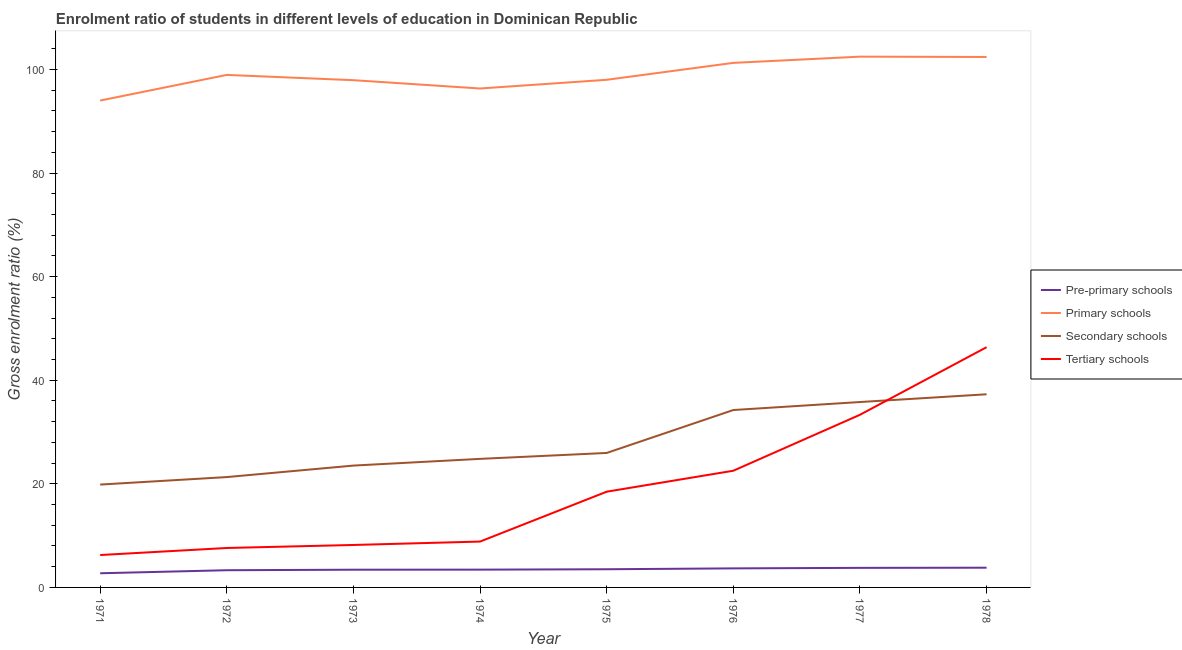Does the line corresponding to gross enrolment ratio in primary schools intersect with the line corresponding to gross enrolment ratio in secondary schools?
Provide a short and direct response. No. What is the gross enrolment ratio in primary schools in 1972?
Your response must be concise. 98.95. Across all years, what is the maximum gross enrolment ratio in primary schools?
Keep it short and to the point. 102.47. Across all years, what is the minimum gross enrolment ratio in pre-primary schools?
Offer a very short reply. 2.73. What is the total gross enrolment ratio in primary schools in the graph?
Offer a terse response. 791.33. What is the difference between the gross enrolment ratio in tertiary schools in 1971 and that in 1976?
Make the answer very short. -16.27. What is the difference between the gross enrolment ratio in pre-primary schools in 1978 and the gross enrolment ratio in secondary schools in 1973?
Give a very brief answer. -19.71. What is the average gross enrolment ratio in primary schools per year?
Make the answer very short. 98.92. In the year 1975, what is the difference between the gross enrolment ratio in primary schools and gross enrolment ratio in pre-primary schools?
Provide a short and direct response. 94.49. In how many years, is the gross enrolment ratio in tertiary schools greater than 56 %?
Keep it short and to the point. 0. What is the ratio of the gross enrolment ratio in primary schools in 1972 to that in 1978?
Provide a succinct answer. 0.97. Is the gross enrolment ratio in tertiary schools in 1973 less than that in 1977?
Provide a succinct answer. Yes. What is the difference between the highest and the second highest gross enrolment ratio in tertiary schools?
Offer a terse response. 13.05. What is the difference between the highest and the lowest gross enrolment ratio in primary schools?
Your answer should be very brief. 8.47. In how many years, is the gross enrolment ratio in pre-primary schools greater than the average gross enrolment ratio in pre-primary schools taken over all years?
Offer a terse response. 4. Is the sum of the gross enrolment ratio in pre-primary schools in 1974 and 1977 greater than the maximum gross enrolment ratio in secondary schools across all years?
Offer a terse response. No. Is it the case that in every year, the sum of the gross enrolment ratio in pre-primary schools and gross enrolment ratio in primary schools is greater than the gross enrolment ratio in secondary schools?
Ensure brevity in your answer.  Yes. Does the gross enrolment ratio in tertiary schools monotonically increase over the years?
Your response must be concise. Yes. How many lines are there?
Make the answer very short. 4. Are the values on the major ticks of Y-axis written in scientific E-notation?
Make the answer very short. No. Does the graph contain grids?
Your answer should be very brief. No. What is the title of the graph?
Keep it short and to the point. Enrolment ratio of students in different levels of education in Dominican Republic. Does "Management rating" appear as one of the legend labels in the graph?
Offer a very short reply. No. What is the Gross enrolment ratio (%) of Pre-primary schools in 1971?
Give a very brief answer. 2.73. What is the Gross enrolment ratio (%) in Primary schools in 1971?
Make the answer very short. 93.99. What is the Gross enrolment ratio (%) of Secondary schools in 1971?
Ensure brevity in your answer.  19.86. What is the Gross enrolment ratio (%) of Tertiary schools in 1971?
Give a very brief answer. 6.25. What is the Gross enrolment ratio (%) of Pre-primary schools in 1972?
Offer a very short reply. 3.32. What is the Gross enrolment ratio (%) of Primary schools in 1972?
Give a very brief answer. 98.95. What is the Gross enrolment ratio (%) of Secondary schools in 1972?
Give a very brief answer. 21.3. What is the Gross enrolment ratio (%) of Tertiary schools in 1972?
Make the answer very short. 7.61. What is the Gross enrolment ratio (%) in Pre-primary schools in 1973?
Provide a succinct answer. 3.42. What is the Gross enrolment ratio (%) in Primary schools in 1973?
Your answer should be very brief. 97.93. What is the Gross enrolment ratio (%) of Secondary schools in 1973?
Make the answer very short. 23.52. What is the Gross enrolment ratio (%) of Tertiary schools in 1973?
Ensure brevity in your answer.  8.2. What is the Gross enrolment ratio (%) in Pre-primary schools in 1974?
Give a very brief answer. 3.43. What is the Gross enrolment ratio (%) of Primary schools in 1974?
Ensure brevity in your answer.  96.32. What is the Gross enrolment ratio (%) of Secondary schools in 1974?
Offer a terse response. 24.82. What is the Gross enrolment ratio (%) of Tertiary schools in 1974?
Offer a terse response. 8.85. What is the Gross enrolment ratio (%) of Pre-primary schools in 1975?
Your response must be concise. 3.51. What is the Gross enrolment ratio (%) of Primary schools in 1975?
Offer a terse response. 98. What is the Gross enrolment ratio (%) in Secondary schools in 1975?
Make the answer very short. 25.96. What is the Gross enrolment ratio (%) in Tertiary schools in 1975?
Offer a terse response. 18.48. What is the Gross enrolment ratio (%) of Pre-primary schools in 1976?
Offer a very short reply. 3.68. What is the Gross enrolment ratio (%) of Primary schools in 1976?
Ensure brevity in your answer.  101.27. What is the Gross enrolment ratio (%) in Secondary schools in 1976?
Provide a short and direct response. 34.25. What is the Gross enrolment ratio (%) in Tertiary schools in 1976?
Provide a short and direct response. 22.53. What is the Gross enrolment ratio (%) of Pre-primary schools in 1977?
Offer a very short reply. 3.78. What is the Gross enrolment ratio (%) of Primary schools in 1977?
Your answer should be compact. 102.47. What is the Gross enrolment ratio (%) of Secondary schools in 1977?
Provide a short and direct response. 35.79. What is the Gross enrolment ratio (%) in Tertiary schools in 1977?
Make the answer very short. 33.33. What is the Gross enrolment ratio (%) of Pre-primary schools in 1978?
Make the answer very short. 3.81. What is the Gross enrolment ratio (%) of Primary schools in 1978?
Your answer should be compact. 102.41. What is the Gross enrolment ratio (%) in Secondary schools in 1978?
Your response must be concise. 37.29. What is the Gross enrolment ratio (%) in Tertiary schools in 1978?
Your response must be concise. 46.38. Across all years, what is the maximum Gross enrolment ratio (%) in Pre-primary schools?
Give a very brief answer. 3.81. Across all years, what is the maximum Gross enrolment ratio (%) of Primary schools?
Provide a succinct answer. 102.47. Across all years, what is the maximum Gross enrolment ratio (%) of Secondary schools?
Keep it short and to the point. 37.29. Across all years, what is the maximum Gross enrolment ratio (%) in Tertiary schools?
Keep it short and to the point. 46.38. Across all years, what is the minimum Gross enrolment ratio (%) of Pre-primary schools?
Offer a very short reply. 2.73. Across all years, what is the minimum Gross enrolment ratio (%) in Primary schools?
Keep it short and to the point. 93.99. Across all years, what is the minimum Gross enrolment ratio (%) of Secondary schools?
Your answer should be compact. 19.86. Across all years, what is the minimum Gross enrolment ratio (%) in Tertiary schools?
Make the answer very short. 6.25. What is the total Gross enrolment ratio (%) in Pre-primary schools in the graph?
Keep it short and to the point. 27.69. What is the total Gross enrolment ratio (%) of Primary schools in the graph?
Keep it short and to the point. 791.33. What is the total Gross enrolment ratio (%) of Secondary schools in the graph?
Your response must be concise. 222.79. What is the total Gross enrolment ratio (%) in Tertiary schools in the graph?
Your response must be concise. 151.64. What is the difference between the Gross enrolment ratio (%) in Pre-primary schools in 1971 and that in 1972?
Your answer should be very brief. -0.59. What is the difference between the Gross enrolment ratio (%) in Primary schools in 1971 and that in 1972?
Keep it short and to the point. -4.95. What is the difference between the Gross enrolment ratio (%) in Secondary schools in 1971 and that in 1972?
Make the answer very short. -1.45. What is the difference between the Gross enrolment ratio (%) of Tertiary schools in 1971 and that in 1972?
Offer a terse response. -1.36. What is the difference between the Gross enrolment ratio (%) of Pre-primary schools in 1971 and that in 1973?
Your response must be concise. -0.69. What is the difference between the Gross enrolment ratio (%) of Primary schools in 1971 and that in 1973?
Your answer should be compact. -3.93. What is the difference between the Gross enrolment ratio (%) in Secondary schools in 1971 and that in 1973?
Provide a short and direct response. -3.67. What is the difference between the Gross enrolment ratio (%) of Tertiary schools in 1971 and that in 1973?
Provide a succinct answer. -1.94. What is the difference between the Gross enrolment ratio (%) of Pre-primary schools in 1971 and that in 1974?
Provide a short and direct response. -0.7. What is the difference between the Gross enrolment ratio (%) in Primary schools in 1971 and that in 1974?
Provide a short and direct response. -2.33. What is the difference between the Gross enrolment ratio (%) of Secondary schools in 1971 and that in 1974?
Your answer should be very brief. -4.96. What is the difference between the Gross enrolment ratio (%) of Tertiary schools in 1971 and that in 1974?
Ensure brevity in your answer.  -2.6. What is the difference between the Gross enrolment ratio (%) of Pre-primary schools in 1971 and that in 1975?
Your answer should be compact. -0.78. What is the difference between the Gross enrolment ratio (%) in Primary schools in 1971 and that in 1975?
Offer a terse response. -4.01. What is the difference between the Gross enrolment ratio (%) in Secondary schools in 1971 and that in 1975?
Provide a succinct answer. -6.1. What is the difference between the Gross enrolment ratio (%) in Tertiary schools in 1971 and that in 1975?
Offer a terse response. -12.23. What is the difference between the Gross enrolment ratio (%) of Pre-primary schools in 1971 and that in 1976?
Provide a succinct answer. -0.94. What is the difference between the Gross enrolment ratio (%) of Primary schools in 1971 and that in 1976?
Your response must be concise. -7.27. What is the difference between the Gross enrolment ratio (%) in Secondary schools in 1971 and that in 1976?
Your response must be concise. -14.39. What is the difference between the Gross enrolment ratio (%) in Tertiary schools in 1971 and that in 1976?
Provide a succinct answer. -16.27. What is the difference between the Gross enrolment ratio (%) in Pre-primary schools in 1971 and that in 1977?
Your answer should be compact. -1.04. What is the difference between the Gross enrolment ratio (%) in Primary schools in 1971 and that in 1977?
Keep it short and to the point. -8.47. What is the difference between the Gross enrolment ratio (%) of Secondary schools in 1971 and that in 1977?
Your answer should be very brief. -15.93. What is the difference between the Gross enrolment ratio (%) in Tertiary schools in 1971 and that in 1977?
Offer a very short reply. -27.08. What is the difference between the Gross enrolment ratio (%) in Pre-primary schools in 1971 and that in 1978?
Offer a terse response. -1.07. What is the difference between the Gross enrolment ratio (%) in Primary schools in 1971 and that in 1978?
Make the answer very short. -8.41. What is the difference between the Gross enrolment ratio (%) of Secondary schools in 1971 and that in 1978?
Keep it short and to the point. -17.43. What is the difference between the Gross enrolment ratio (%) of Tertiary schools in 1971 and that in 1978?
Ensure brevity in your answer.  -40.12. What is the difference between the Gross enrolment ratio (%) in Pre-primary schools in 1972 and that in 1973?
Offer a very short reply. -0.1. What is the difference between the Gross enrolment ratio (%) of Primary schools in 1972 and that in 1973?
Give a very brief answer. 1.02. What is the difference between the Gross enrolment ratio (%) of Secondary schools in 1972 and that in 1973?
Keep it short and to the point. -2.22. What is the difference between the Gross enrolment ratio (%) in Tertiary schools in 1972 and that in 1973?
Ensure brevity in your answer.  -0.58. What is the difference between the Gross enrolment ratio (%) in Pre-primary schools in 1972 and that in 1974?
Provide a succinct answer. -0.11. What is the difference between the Gross enrolment ratio (%) in Primary schools in 1972 and that in 1974?
Your response must be concise. 2.62. What is the difference between the Gross enrolment ratio (%) in Secondary schools in 1972 and that in 1974?
Keep it short and to the point. -3.51. What is the difference between the Gross enrolment ratio (%) in Tertiary schools in 1972 and that in 1974?
Offer a terse response. -1.24. What is the difference between the Gross enrolment ratio (%) in Pre-primary schools in 1972 and that in 1975?
Give a very brief answer. -0.19. What is the difference between the Gross enrolment ratio (%) in Primary schools in 1972 and that in 1975?
Provide a succinct answer. 0.94. What is the difference between the Gross enrolment ratio (%) in Secondary schools in 1972 and that in 1975?
Your response must be concise. -4.66. What is the difference between the Gross enrolment ratio (%) of Tertiary schools in 1972 and that in 1975?
Give a very brief answer. -10.87. What is the difference between the Gross enrolment ratio (%) in Pre-primary schools in 1972 and that in 1976?
Provide a succinct answer. -0.36. What is the difference between the Gross enrolment ratio (%) in Primary schools in 1972 and that in 1976?
Provide a succinct answer. -2.32. What is the difference between the Gross enrolment ratio (%) of Secondary schools in 1972 and that in 1976?
Offer a very short reply. -12.94. What is the difference between the Gross enrolment ratio (%) of Tertiary schools in 1972 and that in 1976?
Your answer should be compact. -14.91. What is the difference between the Gross enrolment ratio (%) of Pre-primary schools in 1972 and that in 1977?
Ensure brevity in your answer.  -0.46. What is the difference between the Gross enrolment ratio (%) in Primary schools in 1972 and that in 1977?
Provide a short and direct response. -3.52. What is the difference between the Gross enrolment ratio (%) in Secondary schools in 1972 and that in 1977?
Your answer should be compact. -14.49. What is the difference between the Gross enrolment ratio (%) of Tertiary schools in 1972 and that in 1977?
Make the answer very short. -25.71. What is the difference between the Gross enrolment ratio (%) of Pre-primary schools in 1972 and that in 1978?
Keep it short and to the point. -0.49. What is the difference between the Gross enrolment ratio (%) in Primary schools in 1972 and that in 1978?
Keep it short and to the point. -3.46. What is the difference between the Gross enrolment ratio (%) of Secondary schools in 1972 and that in 1978?
Offer a very short reply. -15.98. What is the difference between the Gross enrolment ratio (%) in Tertiary schools in 1972 and that in 1978?
Keep it short and to the point. -38.76. What is the difference between the Gross enrolment ratio (%) of Pre-primary schools in 1973 and that in 1974?
Give a very brief answer. -0.01. What is the difference between the Gross enrolment ratio (%) in Primary schools in 1973 and that in 1974?
Provide a short and direct response. 1.6. What is the difference between the Gross enrolment ratio (%) of Secondary schools in 1973 and that in 1974?
Your response must be concise. -1.3. What is the difference between the Gross enrolment ratio (%) in Tertiary schools in 1973 and that in 1974?
Give a very brief answer. -0.66. What is the difference between the Gross enrolment ratio (%) of Pre-primary schools in 1973 and that in 1975?
Offer a terse response. -0.09. What is the difference between the Gross enrolment ratio (%) in Primary schools in 1973 and that in 1975?
Provide a succinct answer. -0.07. What is the difference between the Gross enrolment ratio (%) of Secondary schools in 1973 and that in 1975?
Provide a short and direct response. -2.44. What is the difference between the Gross enrolment ratio (%) of Tertiary schools in 1973 and that in 1975?
Keep it short and to the point. -10.28. What is the difference between the Gross enrolment ratio (%) of Pre-primary schools in 1973 and that in 1976?
Offer a terse response. -0.26. What is the difference between the Gross enrolment ratio (%) in Primary schools in 1973 and that in 1976?
Offer a terse response. -3.34. What is the difference between the Gross enrolment ratio (%) of Secondary schools in 1973 and that in 1976?
Your response must be concise. -10.73. What is the difference between the Gross enrolment ratio (%) of Tertiary schools in 1973 and that in 1976?
Your answer should be compact. -14.33. What is the difference between the Gross enrolment ratio (%) of Pre-primary schools in 1973 and that in 1977?
Give a very brief answer. -0.36. What is the difference between the Gross enrolment ratio (%) in Primary schools in 1973 and that in 1977?
Your answer should be compact. -4.54. What is the difference between the Gross enrolment ratio (%) of Secondary schools in 1973 and that in 1977?
Your answer should be very brief. -12.27. What is the difference between the Gross enrolment ratio (%) in Tertiary schools in 1973 and that in 1977?
Your answer should be very brief. -25.13. What is the difference between the Gross enrolment ratio (%) of Pre-primary schools in 1973 and that in 1978?
Make the answer very short. -0.39. What is the difference between the Gross enrolment ratio (%) of Primary schools in 1973 and that in 1978?
Provide a succinct answer. -4.48. What is the difference between the Gross enrolment ratio (%) of Secondary schools in 1973 and that in 1978?
Make the answer very short. -13.77. What is the difference between the Gross enrolment ratio (%) of Tertiary schools in 1973 and that in 1978?
Give a very brief answer. -38.18. What is the difference between the Gross enrolment ratio (%) in Pre-primary schools in 1974 and that in 1975?
Offer a very short reply. -0.08. What is the difference between the Gross enrolment ratio (%) of Primary schools in 1974 and that in 1975?
Keep it short and to the point. -1.68. What is the difference between the Gross enrolment ratio (%) in Secondary schools in 1974 and that in 1975?
Your answer should be compact. -1.14. What is the difference between the Gross enrolment ratio (%) of Tertiary schools in 1974 and that in 1975?
Your answer should be very brief. -9.63. What is the difference between the Gross enrolment ratio (%) in Pre-primary schools in 1974 and that in 1976?
Provide a succinct answer. -0.24. What is the difference between the Gross enrolment ratio (%) of Primary schools in 1974 and that in 1976?
Your response must be concise. -4.95. What is the difference between the Gross enrolment ratio (%) in Secondary schools in 1974 and that in 1976?
Your answer should be very brief. -9.43. What is the difference between the Gross enrolment ratio (%) in Tertiary schools in 1974 and that in 1976?
Give a very brief answer. -13.67. What is the difference between the Gross enrolment ratio (%) of Pre-primary schools in 1974 and that in 1977?
Your response must be concise. -0.34. What is the difference between the Gross enrolment ratio (%) in Primary schools in 1974 and that in 1977?
Your response must be concise. -6.15. What is the difference between the Gross enrolment ratio (%) of Secondary schools in 1974 and that in 1977?
Your answer should be very brief. -10.97. What is the difference between the Gross enrolment ratio (%) in Tertiary schools in 1974 and that in 1977?
Offer a very short reply. -24.47. What is the difference between the Gross enrolment ratio (%) in Pre-primary schools in 1974 and that in 1978?
Your answer should be compact. -0.37. What is the difference between the Gross enrolment ratio (%) of Primary schools in 1974 and that in 1978?
Give a very brief answer. -6.09. What is the difference between the Gross enrolment ratio (%) of Secondary schools in 1974 and that in 1978?
Provide a short and direct response. -12.47. What is the difference between the Gross enrolment ratio (%) in Tertiary schools in 1974 and that in 1978?
Your answer should be very brief. -37.52. What is the difference between the Gross enrolment ratio (%) in Pre-primary schools in 1975 and that in 1976?
Offer a very short reply. -0.17. What is the difference between the Gross enrolment ratio (%) in Primary schools in 1975 and that in 1976?
Make the answer very short. -3.27. What is the difference between the Gross enrolment ratio (%) in Secondary schools in 1975 and that in 1976?
Your response must be concise. -8.29. What is the difference between the Gross enrolment ratio (%) of Tertiary schools in 1975 and that in 1976?
Your response must be concise. -4.05. What is the difference between the Gross enrolment ratio (%) in Pre-primary schools in 1975 and that in 1977?
Provide a succinct answer. -0.27. What is the difference between the Gross enrolment ratio (%) of Primary schools in 1975 and that in 1977?
Your answer should be compact. -4.47. What is the difference between the Gross enrolment ratio (%) in Secondary schools in 1975 and that in 1977?
Provide a succinct answer. -9.83. What is the difference between the Gross enrolment ratio (%) in Tertiary schools in 1975 and that in 1977?
Your response must be concise. -14.85. What is the difference between the Gross enrolment ratio (%) of Pre-primary schools in 1975 and that in 1978?
Your answer should be very brief. -0.3. What is the difference between the Gross enrolment ratio (%) of Primary schools in 1975 and that in 1978?
Your response must be concise. -4.41. What is the difference between the Gross enrolment ratio (%) of Secondary schools in 1975 and that in 1978?
Your answer should be compact. -11.33. What is the difference between the Gross enrolment ratio (%) of Tertiary schools in 1975 and that in 1978?
Provide a short and direct response. -27.9. What is the difference between the Gross enrolment ratio (%) in Pre-primary schools in 1976 and that in 1977?
Your answer should be compact. -0.1. What is the difference between the Gross enrolment ratio (%) of Primary schools in 1976 and that in 1977?
Your answer should be compact. -1.2. What is the difference between the Gross enrolment ratio (%) of Secondary schools in 1976 and that in 1977?
Give a very brief answer. -1.54. What is the difference between the Gross enrolment ratio (%) of Tertiary schools in 1976 and that in 1977?
Your answer should be very brief. -10.8. What is the difference between the Gross enrolment ratio (%) in Pre-primary schools in 1976 and that in 1978?
Provide a short and direct response. -0.13. What is the difference between the Gross enrolment ratio (%) of Primary schools in 1976 and that in 1978?
Provide a succinct answer. -1.14. What is the difference between the Gross enrolment ratio (%) of Secondary schools in 1976 and that in 1978?
Offer a very short reply. -3.04. What is the difference between the Gross enrolment ratio (%) of Tertiary schools in 1976 and that in 1978?
Provide a short and direct response. -23.85. What is the difference between the Gross enrolment ratio (%) of Pre-primary schools in 1977 and that in 1978?
Your answer should be very brief. -0.03. What is the difference between the Gross enrolment ratio (%) in Primary schools in 1977 and that in 1978?
Your response must be concise. 0.06. What is the difference between the Gross enrolment ratio (%) of Secondary schools in 1977 and that in 1978?
Give a very brief answer. -1.5. What is the difference between the Gross enrolment ratio (%) in Tertiary schools in 1977 and that in 1978?
Offer a very short reply. -13.05. What is the difference between the Gross enrolment ratio (%) in Pre-primary schools in 1971 and the Gross enrolment ratio (%) in Primary schools in 1972?
Your answer should be compact. -96.21. What is the difference between the Gross enrolment ratio (%) in Pre-primary schools in 1971 and the Gross enrolment ratio (%) in Secondary schools in 1972?
Offer a terse response. -18.57. What is the difference between the Gross enrolment ratio (%) of Pre-primary schools in 1971 and the Gross enrolment ratio (%) of Tertiary schools in 1972?
Keep it short and to the point. -4.88. What is the difference between the Gross enrolment ratio (%) in Primary schools in 1971 and the Gross enrolment ratio (%) in Secondary schools in 1972?
Provide a succinct answer. 72.69. What is the difference between the Gross enrolment ratio (%) of Primary schools in 1971 and the Gross enrolment ratio (%) of Tertiary schools in 1972?
Provide a succinct answer. 86.38. What is the difference between the Gross enrolment ratio (%) in Secondary schools in 1971 and the Gross enrolment ratio (%) in Tertiary schools in 1972?
Provide a succinct answer. 12.24. What is the difference between the Gross enrolment ratio (%) of Pre-primary schools in 1971 and the Gross enrolment ratio (%) of Primary schools in 1973?
Your answer should be compact. -95.19. What is the difference between the Gross enrolment ratio (%) in Pre-primary schools in 1971 and the Gross enrolment ratio (%) in Secondary schools in 1973?
Your response must be concise. -20.79. What is the difference between the Gross enrolment ratio (%) of Pre-primary schools in 1971 and the Gross enrolment ratio (%) of Tertiary schools in 1973?
Provide a succinct answer. -5.46. What is the difference between the Gross enrolment ratio (%) in Primary schools in 1971 and the Gross enrolment ratio (%) in Secondary schools in 1973?
Give a very brief answer. 70.47. What is the difference between the Gross enrolment ratio (%) of Primary schools in 1971 and the Gross enrolment ratio (%) of Tertiary schools in 1973?
Your answer should be very brief. 85.8. What is the difference between the Gross enrolment ratio (%) in Secondary schools in 1971 and the Gross enrolment ratio (%) in Tertiary schools in 1973?
Ensure brevity in your answer.  11.66. What is the difference between the Gross enrolment ratio (%) in Pre-primary schools in 1971 and the Gross enrolment ratio (%) in Primary schools in 1974?
Provide a succinct answer. -93.59. What is the difference between the Gross enrolment ratio (%) in Pre-primary schools in 1971 and the Gross enrolment ratio (%) in Secondary schools in 1974?
Your response must be concise. -22.08. What is the difference between the Gross enrolment ratio (%) of Pre-primary schools in 1971 and the Gross enrolment ratio (%) of Tertiary schools in 1974?
Offer a terse response. -6.12. What is the difference between the Gross enrolment ratio (%) of Primary schools in 1971 and the Gross enrolment ratio (%) of Secondary schools in 1974?
Offer a very short reply. 69.18. What is the difference between the Gross enrolment ratio (%) in Primary schools in 1971 and the Gross enrolment ratio (%) in Tertiary schools in 1974?
Keep it short and to the point. 85.14. What is the difference between the Gross enrolment ratio (%) of Secondary schools in 1971 and the Gross enrolment ratio (%) of Tertiary schools in 1974?
Your answer should be very brief. 11. What is the difference between the Gross enrolment ratio (%) in Pre-primary schools in 1971 and the Gross enrolment ratio (%) in Primary schools in 1975?
Your answer should be very brief. -95.27. What is the difference between the Gross enrolment ratio (%) of Pre-primary schools in 1971 and the Gross enrolment ratio (%) of Secondary schools in 1975?
Keep it short and to the point. -23.23. What is the difference between the Gross enrolment ratio (%) in Pre-primary schools in 1971 and the Gross enrolment ratio (%) in Tertiary schools in 1975?
Offer a terse response. -15.75. What is the difference between the Gross enrolment ratio (%) of Primary schools in 1971 and the Gross enrolment ratio (%) of Secondary schools in 1975?
Keep it short and to the point. 68.03. What is the difference between the Gross enrolment ratio (%) of Primary schools in 1971 and the Gross enrolment ratio (%) of Tertiary schools in 1975?
Ensure brevity in your answer.  75.51. What is the difference between the Gross enrolment ratio (%) of Secondary schools in 1971 and the Gross enrolment ratio (%) of Tertiary schools in 1975?
Provide a succinct answer. 1.38. What is the difference between the Gross enrolment ratio (%) in Pre-primary schools in 1971 and the Gross enrolment ratio (%) in Primary schools in 1976?
Provide a succinct answer. -98.53. What is the difference between the Gross enrolment ratio (%) of Pre-primary schools in 1971 and the Gross enrolment ratio (%) of Secondary schools in 1976?
Make the answer very short. -31.51. What is the difference between the Gross enrolment ratio (%) in Pre-primary schools in 1971 and the Gross enrolment ratio (%) in Tertiary schools in 1976?
Keep it short and to the point. -19.79. What is the difference between the Gross enrolment ratio (%) of Primary schools in 1971 and the Gross enrolment ratio (%) of Secondary schools in 1976?
Your answer should be compact. 59.75. What is the difference between the Gross enrolment ratio (%) in Primary schools in 1971 and the Gross enrolment ratio (%) in Tertiary schools in 1976?
Make the answer very short. 71.47. What is the difference between the Gross enrolment ratio (%) of Secondary schools in 1971 and the Gross enrolment ratio (%) of Tertiary schools in 1976?
Provide a succinct answer. -2.67. What is the difference between the Gross enrolment ratio (%) of Pre-primary schools in 1971 and the Gross enrolment ratio (%) of Primary schools in 1977?
Your answer should be very brief. -99.73. What is the difference between the Gross enrolment ratio (%) of Pre-primary schools in 1971 and the Gross enrolment ratio (%) of Secondary schools in 1977?
Provide a succinct answer. -33.06. What is the difference between the Gross enrolment ratio (%) in Pre-primary schools in 1971 and the Gross enrolment ratio (%) in Tertiary schools in 1977?
Offer a very short reply. -30.59. What is the difference between the Gross enrolment ratio (%) of Primary schools in 1971 and the Gross enrolment ratio (%) of Secondary schools in 1977?
Your answer should be very brief. 58.2. What is the difference between the Gross enrolment ratio (%) of Primary schools in 1971 and the Gross enrolment ratio (%) of Tertiary schools in 1977?
Your response must be concise. 60.67. What is the difference between the Gross enrolment ratio (%) of Secondary schools in 1971 and the Gross enrolment ratio (%) of Tertiary schools in 1977?
Offer a terse response. -13.47. What is the difference between the Gross enrolment ratio (%) of Pre-primary schools in 1971 and the Gross enrolment ratio (%) of Primary schools in 1978?
Ensure brevity in your answer.  -99.67. What is the difference between the Gross enrolment ratio (%) in Pre-primary schools in 1971 and the Gross enrolment ratio (%) in Secondary schools in 1978?
Ensure brevity in your answer.  -34.55. What is the difference between the Gross enrolment ratio (%) of Pre-primary schools in 1971 and the Gross enrolment ratio (%) of Tertiary schools in 1978?
Offer a very short reply. -43.64. What is the difference between the Gross enrolment ratio (%) of Primary schools in 1971 and the Gross enrolment ratio (%) of Secondary schools in 1978?
Your response must be concise. 56.71. What is the difference between the Gross enrolment ratio (%) of Primary schools in 1971 and the Gross enrolment ratio (%) of Tertiary schools in 1978?
Give a very brief answer. 47.62. What is the difference between the Gross enrolment ratio (%) in Secondary schools in 1971 and the Gross enrolment ratio (%) in Tertiary schools in 1978?
Your answer should be compact. -26.52. What is the difference between the Gross enrolment ratio (%) of Pre-primary schools in 1972 and the Gross enrolment ratio (%) of Primary schools in 1973?
Offer a very short reply. -94.61. What is the difference between the Gross enrolment ratio (%) of Pre-primary schools in 1972 and the Gross enrolment ratio (%) of Secondary schools in 1973?
Your answer should be very brief. -20.2. What is the difference between the Gross enrolment ratio (%) in Pre-primary schools in 1972 and the Gross enrolment ratio (%) in Tertiary schools in 1973?
Ensure brevity in your answer.  -4.88. What is the difference between the Gross enrolment ratio (%) in Primary schools in 1972 and the Gross enrolment ratio (%) in Secondary schools in 1973?
Give a very brief answer. 75.42. What is the difference between the Gross enrolment ratio (%) of Primary schools in 1972 and the Gross enrolment ratio (%) of Tertiary schools in 1973?
Your answer should be compact. 90.75. What is the difference between the Gross enrolment ratio (%) in Secondary schools in 1972 and the Gross enrolment ratio (%) in Tertiary schools in 1973?
Make the answer very short. 13.11. What is the difference between the Gross enrolment ratio (%) of Pre-primary schools in 1972 and the Gross enrolment ratio (%) of Primary schools in 1974?
Offer a terse response. -93. What is the difference between the Gross enrolment ratio (%) of Pre-primary schools in 1972 and the Gross enrolment ratio (%) of Secondary schools in 1974?
Your answer should be compact. -21.5. What is the difference between the Gross enrolment ratio (%) in Pre-primary schools in 1972 and the Gross enrolment ratio (%) in Tertiary schools in 1974?
Provide a succinct answer. -5.53. What is the difference between the Gross enrolment ratio (%) in Primary schools in 1972 and the Gross enrolment ratio (%) in Secondary schools in 1974?
Provide a short and direct response. 74.13. What is the difference between the Gross enrolment ratio (%) of Primary schools in 1972 and the Gross enrolment ratio (%) of Tertiary schools in 1974?
Give a very brief answer. 90.09. What is the difference between the Gross enrolment ratio (%) of Secondary schools in 1972 and the Gross enrolment ratio (%) of Tertiary schools in 1974?
Your answer should be compact. 12.45. What is the difference between the Gross enrolment ratio (%) of Pre-primary schools in 1972 and the Gross enrolment ratio (%) of Primary schools in 1975?
Offer a very short reply. -94.68. What is the difference between the Gross enrolment ratio (%) of Pre-primary schools in 1972 and the Gross enrolment ratio (%) of Secondary schools in 1975?
Keep it short and to the point. -22.64. What is the difference between the Gross enrolment ratio (%) in Pre-primary schools in 1972 and the Gross enrolment ratio (%) in Tertiary schools in 1975?
Make the answer very short. -15.16. What is the difference between the Gross enrolment ratio (%) of Primary schools in 1972 and the Gross enrolment ratio (%) of Secondary schools in 1975?
Provide a short and direct response. 72.98. What is the difference between the Gross enrolment ratio (%) of Primary schools in 1972 and the Gross enrolment ratio (%) of Tertiary schools in 1975?
Provide a succinct answer. 80.46. What is the difference between the Gross enrolment ratio (%) of Secondary schools in 1972 and the Gross enrolment ratio (%) of Tertiary schools in 1975?
Make the answer very short. 2.82. What is the difference between the Gross enrolment ratio (%) in Pre-primary schools in 1972 and the Gross enrolment ratio (%) in Primary schools in 1976?
Your answer should be compact. -97.95. What is the difference between the Gross enrolment ratio (%) in Pre-primary schools in 1972 and the Gross enrolment ratio (%) in Secondary schools in 1976?
Your answer should be compact. -30.93. What is the difference between the Gross enrolment ratio (%) of Pre-primary schools in 1972 and the Gross enrolment ratio (%) of Tertiary schools in 1976?
Ensure brevity in your answer.  -19.21. What is the difference between the Gross enrolment ratio (%) in Primary schools in 1972 and the Gross enrolment ratio (%) in Secondary schools in 1976?
Ensure brevity in your answer.  64.7. What is the difference between the Gross enrolment ratio (%) in Primary schools in 1972 and the Gross enrolment ratio (%) in Tertiary schools in 1976?
Keep it short and to the point. 76.42. What is the difference between the Gross enrolment ratio (%) of Secondary schools in 1972 and the Gross enrolment ratio (%) of Tertiary schools in 1976?
Provide a succinct answer. -1.22. What is the difference between the Gross enrolment ratio (%) of Pre-primary schools in 1972 and the Gross enrolment ratio (%) of Primary schools in 1977?
Make the answer very short. -99.15. What is the difference between the Gross enrolment ratio (%) in Pre-primary schools in 1972 and the Gross enrolment ratio (%) in Secondary schools in 1977?
Provide a succinct answer. -32.47. What is the difference between the Gross enrolment ratio (%) of Pre-primary schools in 1972 and the Gross enrolment ratio (%) of Tertiary schools in 1977?
Provide a short and direct response. -30.01. What is the difference between the Gross enrolment ratio (%) of Primary schools in 1972 and the Gross enrolment ratio (%) of Secondary schools in 1977?
Make the answer very short. 63.15. What is the difference between the Gross enrolment ratio (%) of Primary schools in 1972 and the Gross enrolment ratio (%) of Tertiary schools in 1977?
Your answer should be compact. 65.62. What is the difference between the Gross enrolment ratio (%) of Secondary schools in 1972 and the Gross enrolment ratio (%) of Tertiary schools in 1977?
Provide a short and direct response. -12.02. What is the difference between the Gross enrolment ratio (%) of Pre-primary schools in 1972 and the Gross enrolment ratio (%) of Primary schools in 1978?
Give a very brief answer. -99.09. What is the difference between the Gross enrolment ratio (%) of Pre-primary schools in 1972 and the Gross enrolment ratio (%) of Secondary schools in 1978?
Give a very brief answer. -33.97. What is the difference between the Gross enrolment ratio (%) in Pre-primary schools in 1972 and the Gross enrolment ratio (%) in Tertiary schools in 1978?
Offer a terse response. -43.06. What is the difference between the Gross enrolment ratio (%) of Primary schools in 1972 and the Gross enrolment ratio (%) of Secondary schools in 1978?
Make the answer very short. 61.66. What is the difference between the Gross enrolment ratio (%) in Primary schools in 1972 and the Gross enrolment ratio (%) in Tertiary schools in 1978?
Make the answer very short. 52.57. What is the difference between the Gross enrolment ratio (%) of Secondary schools in 1972 and the Gross enrolment ratio (%) of Tertiary schools in 1978?
Offer a terse response. -25.07. What is the difference between the Gross enrolment ratio (%) of Pre-primary schools in 1973 and the Gross enrolment ratio (%) of Primary schools in 1974?
Provide a succinct answer. -92.9. What is the difference between the Gross enrolment ratio (%) in Pre-primary schools in 1973 and the Gross enrolment ratio (%) in Secondary schools in 1974?
Offer a terse response. -21.4. What is the difference between the Gross enrolment ratio (%) of Pre-primary schools in 1973 and the Gross enrolment ratio (%) of Tertiary schools in 1974?
Provide a succinct answer. -5.43. What is the difference between the Gross enrolment ratio (%) in Primary schools in 1973 and the Gross enrolment ratio (%) in Secondary schools in 1974?
Offer a terse response. 73.11. What is the difference between the Gross enrolment ratio (%) in Primary schools in 1973 and the Gross enrolment ratio (%) in Tertiary schools in 1974?
Provide a succinct answer. 89.07. What is the difference between the Gross enrolment ratio (%) of Secondary schools in 1973 and the Gross enrolment ratio (%) of Tertiary schools in 1974?
Your answer should be very brief. 14.67. What is the difference between the Gross enrolment ratio (%) in Pre-primary schools in 1973 and the Gross enrolment ratio (%) in Primary schools in 1975?
Your answer should be very brief. -94.58. What is the difference between the Gross enrolment ratio (%) in Pre-primary schools in 1973 and the Gross enrolment ratio (%) in Secondary schools in 1975?
Keep it short and to the point. -22.54. What is the difference between the Gross enrolment ratio (%) of Pre-primary schools in 1973 and the Gross enrolment ratio (%) of Tertiary schools in 1975?
Offer a terse response. -15.06. What is the difference between the Gross enrolment ratio (%) in Primary schools in 1973 and the Gross enrolment ratio (%) in Secondary schools in 1975?
Provide a short and direct response. 71.96. What is the difference between the Gross enrolment ratio (%) of Primary schools in 1973 and the Gross enrolment ratio (%) of Tertiary schools in 1975?
Ensure brevity in your answer.  79.44. What is the difference between the Gross enrolment ratio (%) of Secondary schools in 1973 and the Gross enrolment ratio (%) of Tertiary schools in 1975?
Your answer should be very brief. 5.04. What is the difference between the Gross enrolment ratio (%) in Pre-primary schools in 1973 and the Gross enrolment ratio (%) in Primary schools in 1976?
Your answer should be very brief. -97.85. What is the difference between the Gross enrolment ratio (%) of Pre-primary schools in 1973 and the Gross enrolment ratio (%) of Secondary schools in 1976?
Offer a very short reply. -30.83. What is the difference between the Gross enrolment ratio (%) of Pre-primary schools in 1973 and the Gross enrolment ratio (%) of Tertiary schools in 1976?
Offer a terse response. -19.11. What is the difference between the Gross enrolment ratio (%) of Primary schools in 1973 and the Gross enrolment ratio (%) of Secondary schools in 1976?
Offer a very short reply. 63.68. What is the difference between the Gross enrolment ratio (%) of Primary schools in 1973 and the Gross enrolment ratio (%) of Tertiary schools in 1976?
Keep it short and to the point. 75.4. What is the difference between the Gross enrolment ratio (%) in Pre-primary schools in 1973 and the Gross enrolment ratio (%) in Primary schools in 1977?
Ensure brevity in your answer.  -99.05. What is the difference between the Gross enrolment ratio (%) in Pre-primary schools in 1973 and the Gross enrolment ratio (%) in Secondary schools in 1977?
Your answer should be very brief. -32.37. What is the difference between the Gross enrolment ratio (%) in Pre-primary schools in 1973 and the Gross enrolment ratio (%) in Tertiary schools in 1977?
Your answer should be very brief. -29.91. What is the difference between the Gross enrolment ratio (%) of Primary schools in 1973 and the Gross enrolment ratio (%) of Secondary schools in 1977?
Provide a succinct answer. 62.14. What is the difference between the Gross enrolment ratio (%) in Primary schools in 1973 and the Gross enrolment ratio (%) in Tertiary schools in 1977?
Provide a short and direct response. 64.6. What is the difference between the Gross enrolment ratio (%) in Secondary schools in 1973 and the Gross enrolment ratio (%) in Tertiary schools in 1977?
Ensure brevity in your answer.  -9.81. What is the difference between the Gross enrolment ratio (%) of Pre-primary schools in 1973 and the Gross enrolment ratio (%) of Primary schools in 1978?
Give a very brief answer. -98.99. What is the difference between the Gross enrolment ratio (%) in Pre-primary schools in 1973 and the Gross enrolment ratio (%) in Secondary schools in 1978?
Keep it short and to the point. -33.87. What is the difference between the Gross enrolment ratio (%) of Pre-primary schools in 1973 and the Gross enrolment ratio (%) of Tertiary schools in 1978?
Your answer should be very brief. -42.96. What is the difference between the Gross enrolment ratio (%) in Primary schools in 1973 and the Gross enrolment ratio (%) in Secondary schools in 1978?
Offer a very short reply. 60.64. What is the difference between the Gross enrolment ratio (%) in Primary schools in 1973 and the Gross enrolment ratio (%) in Tertiary schools in 1978?
Offer a very short reply. 51.55. What is the difference between the Gross enrolment ratio (%) in Secondary schools in 1973 and the Gross enrolment ratio (%) in Tertiary schools in 1978?
Offer a terse response. -22.85. What is the difference between the Gross enrolment ratio (%) in Pre-primary schools in 1974 and the Gross enrolment ratio (%) in Primary schools in 1975?
Keep it short and to the point. -94.57. What is the difference between the Gross enrolment ratio (%) in Pre-primary schools in 1974 and the Gross enrolment ratio (%) in Secondary schools in 1975?
Keep it short and to the point. -22.53. What is the difference between the Gross enrolment ratio (%) in Pre-primary schools in 1974 and the Gross enrolment ratio (%) in Tertiary schools in 1975?
Offer a terse response. -15.05. What is the difference between the Gross enrolment ratio (%) of Primary schools in 1974 and the Gross enrolment ratio (%) of Secondary schools in 1975?
Your answer should be compact. 70.36. What is the difference between the Gross enrolment ratio (%) of Primary schools in 1974 and the Gross enrolment ratio (%) of Tertiary schools in 1975?
Make the answer very short. 77.84. What is the difference between the Gross enrolment ratio (%) of Secondary schools in 1974 and the Gross enrolment ratio (%) of Tertiary schools in 1975?
Make the answer very short. 6.34. What is the difference between the Gross enrolment ratio (%) of Pre-primary schools in 1974 and the Gross enrolment ratio (%) of Primary schools in 1976?
Ensure brevity in your answer.  -97.83. What is the difference between the Gross enrolment ratio (%) in Pre-primary schools in 1974 and the Gross enrolment ratio (%) in Secondary schools in 1976?
Ensure brevity in your answer.  -30.81. What is the difference between the Gross enrolment ratio (%) in Pre-primary schools in 1974 and the Gross enrolment ratio (%) in Tertiary schools in 1976?
Give a very brief answer. -19.09. What is the difference between the Gross enrolment ratio (%) in Primary schools in 1974 and the Gross enrolment ratio (%) in Secondary schools in 1976?
Your response must be concise. 62.07. What is the difference between the Gross enrolment ratio (%) in Primary schools in 1974 and the Gross enrolment ratio (%) in Tertiary schools in 1976?
Provide a succinct answer. 73.79. What is the difference between the Gross enrolment ratio (%) in Secondary schools in 1974 and the Gross enrolment ratio (%) in Tertiary schools in 1976?
Make the answer very short. 2.29. What is the difference between the Gross enrolment ratio (%) in Pre-primary schools in 1974 and the Gross enrolment ratio (%) in Primary schools in 1977?
Your answer should be compact. -99.03. What is the difference between the Gross enrolment ratio (%) of Pre-primary schools in 1974 and the Gross enrolment ratio (%) of Secondary schools in 1977?
Provide a succinct answer. -32.36. What is the difference between the Gross enrolment ratio (%) in Pre-primary schools in 1974 and the Gross enrolment ratio (%) in Tertiary schools in 1977?
Your answer should be compact. -29.89. What is the difference between the Gross enrolment ratio (%) in Primary schools in 1974 and the Gross enrolment ratio (%) in Secondary schools in 1977?
Provide a short and direct response. 60.53. What is the difference between the Gross enrolment ratio (%) of Primary schools in 1974 and the Gross enrolment ratio (%) of Tertiary schools in 1977?
Provide a succinct answer. 62.99. What is the difference between the Gross enrolment ratio (%) in Secondary schools in 1974 and the Gross enrolment ratio (%) in Tertiary schools in 1977?
Your answer should be compact. -8.51. What is the difference between the Gross enrolment ratio (%) of Pre-primary schools in 1974 and the Gross enrolment ratio (%) of Primary schools in 1978?
Offer a very short reply. -98.97. What is the difference between the Gross enrolment ratio (%) of Pre-primary schools in 1974 and the Gross enrolment ratio (%) of Secondary schools in 1978?
Your answer should be very brief. -33.85. What is the difference between the Gross enrolment ratio (%) in Pre-primary schools in 1974 and the Gross enrolment ratio (%) in Tertiary schools in 1978?
Your answer should be compact. -42.94. What is the difference between the Gross enrolment ratio (%) in Primary schools in 1974 and the Gross enrolment ratio (%) in Secondary schools in 1978?
Offer a terse response. 59.03. What is the difference between the Gross enrolment ratio (%) in Primary schools in 1974 and the Gross enrolment ratio (%) in Tertiary schools in 1978?
Your response must be concise. 49.94. What is the difference between the Gross enrolment ratio (%) of Secondary schools in 1974 and the Gross enrolment ratio (%) of Tertiary schools in 1978?
Offer a very short reply. -21.56. What is the difference between the Gross enrolment ratio (%) in Pre-primary schools in 1975 and the Gross enrolment ratio (%) in Primary schools in 1976?
Make the answer very short. -97.76. What is the difference between the Gross enrolment ratio (%) in Pre-primary schools in 1975 and the Gross enrolment ratio (%) in Secondary schools in 1976?
Ensure brevity in your answer.  -30.74. What is the difference between the Gross enrolment ratio (%) of Pre-primary schools in 1975 and the Gross enrolment ratio (%) of Tertiary schools in 1976?
Your answer should be very brief. -19.02. What is the difference between the Gross enrolment ratio (%) of Primary schools in 1975 and the Gross enrolment ratio (%) of Secondary schools in 1976?
Provide a short and direct response. 63.75. What is the difference between the Gross enrolment ratio (%) in Primary schools in 1975 and the Gross enrolment ratio (%) in Tertiary schools in 1976?
Keep it short and to the point. 75.47. What is the difference between the Gross enrolment ratio (%) of Secondary schools in 1975 and the Gross enrolment ratio (%) of Tertiary schools in 1976?
Keep it short and to the point. 3.43. What is the difference between the Gross enrolment ratio (%) in Pre-primary schools in 1975 and the Gross enrolment ratio (%) in Primary schools in 1977?
Provide a short and direct response. -98.96. What is the difference between the Gross enrolment ratio (%) in Pre-primary schools in 1975 and the Gross enrolment ratio (%) in Secondary schools in 1977?
Your response must be concise. -32.28. What is the difference between the Gross enrolment ratio (%) in Pre-primary schools in 1975 and the Gross enrolment ratio (%) in Tertiary schools in 1977?
Your answer should be very brief. -29.82. What is the difference between the Gross enrolment ratio (%) of Primary schools in 1975 and the Gross enrolment ratio (%) of Secondary schools in 1977?
Provide a short and direct response. 62.21. What is the difference between the Gross enrolment ratio (%) of Primary schools in 1975 and the Gross enrolment ratio (%) of Tertiary schools in 1977?
Offer a terse response. 64.67. What is the difference between the Gross enrolment ratio (%) of Secondary schools in 1975 and the Gross enrolment ratio (%) of Tertiary schools in 1977?
Offer a very short reply. -7.37. What is the difference between the Gross enrolment ratio (%) in Pre-primary schools in 1975 and the Gross enrolment ratio (%) in Primary schools in 1978?
Provide a succinct answer. -98.9. What is the difference between the Gross enrolment ratio (%) in Pre-primary schools in 1975 and the Gross enrolment ratio (%) in Secondary schools in 1978?
Your answer should be compact. -33.78. What is the difference between the Gross enrolment ratio (%) of Pre-primary schools in 1975 and the Gross enrolment ratio (%) of Tertiary schools in 1978?
Your response must be concise. -42.87. What is the difference between the Gross enrolment ratio (%) in Primary schools in 1975 and the Gross enrolment ratio (%) in Secondary schools in 1978?
Offer a terse response. 60.71. What is the difference between the Gross enrolment ratio (%) in Primary schools in 1975 and the Gross enrolment ratio (%) in Tertiary schools in 1978?
Provide a succinct answer. 51.62. What is the difference between the Gross enrolment ratio (%) of Secondary schools in 1975 and the Gross enrolment ratio (%) of Tertiary schools in 1978?
Provide a succinct answer. -20.42. What is the difference between the Gross enrolment ratio (%) of Pre-primary schools in 1976 and the Gross enrolment ratio (%) of Primary schools in 1977?
Your answer should be very brief. -98.79. What is the difference between the Gross enrolment ratio (%) of Pre-primary schools in 1976 and the Gross enrolment ratio (%) of Secondary schools in 1977?
Provide a succinct answer. -32.11. What is the difference between the Gross enrolment ratio (%) in Pre-primary schools in 1976 and the Gross enrolment ratio (%) in Tertiary schools in 1977?
Your answer should be compact. -29.65. What is the difference between the Gross enrolment ratio (%) of Primary schools in 1976 and the Gross enrolment ratio (%) of Secondary schools in 1977?
Offer a very short reply. 65.48. What is the difference between the Gross enrolment ratio (%) in Primary schools in 1976 and the Gross enrolment ratio (%) in Tertiary schools in 1977?
Offer a terse response. 67.94. What is the difference between the Gross enrolment ratio (%) in Secondary schools in 1976 and the Gross enrolment ratio (%) in Tertiary schools in 1977?
Provide a short and direct response. 0.92. What is the difference between the Gross enrolment ratio (%) in Pre-primary schools in 1976 and the Gross enrolment ratio (%) in Primary schools in 1978?
Your response must be concise. -98.73. What is the difference between the Gross enrolment ratio (%) of Pre-primary schools in 1976 and the Gross enrolment ratio (%) of Secondary schools in 1978?
Offer a terse response. -33.61. What is the difference between the Gross enrolment ratio (%) in Pre-primary schools in 1976 and the Gross enrolment ratio (%) in Tertiary schools in 1978?
Provide a succinct answer. -42.7. What is the difference between the Gross enrolment ratio (%) of Primary schools in 1976 and the Gross enrolment ratio (%) of Secondary schools in 1978?
Offer a terse response. 63.98. What is the difference between the Gross enrolment ratio (%) in Primary schools in 1976 and the Gross enrolment ratio (%) in Tertiary schools in 1978?
Give a very brief answer. 54.89. What is the difference between the Gross enrolment ratio (%) in Secondary schools in 1976 and the Gross enrolment ratio (%) in Tertiary schools in 1978?
Your response must be concise. -12.13. What is the difference between the Gross enrolment ratio (%) of Pre-primary schools in 1977 and the Gross enrolment ratio (%) of Primary schools in 1978?
Offer a very short reply. -98.63. What is the difference between the Gross enrolment ratio (%) in Pre-primary schools in 1977 and the Gross enrolment ratio (%) in Secondary schools in 1978?
Your answer should be very brief. -33.51. What is the difference between the Gross enrolment ratio (%) in Pre-primary schools in 1977 and the Gross enrolment ratio (%) in Tertiary schools in 1978?
Offer a terse response. -42.6. What is the difference between the Gross enrolment ratio (%) of Primary schools in 1977 and the Gross enrolment ratio (%) of Secondary schools in 1978?
Provide a short and direct response. 65.18. What is the difference between the Gross enrolment ratio (%) of Primary schools in 1977 and the Gross enrolment ratio (%) of Tertiary schools in 1978?
Your answer should be compact. 56.09. What is the difference between the Gross enrolment ratio (%) of Secondary schools in 1977 and the Gross enrolment ratio (%) of Tertiary schools in 1978?
Make the answer very short. -10.59. What is the average Gross enrolment ratio (%) in Pre-primary schools per year?
Your answer should be compact. 3.46. What is the average Gross enrolment ratio (%) in Primary schools per year?
Keep it short and to the point. 98.92. What is the average Gross enrolment ratio (%) in Secondary schools per year?
Provide a short and direct response. 27.85. What is the average Gross enrolment ratio (%) in Tertiary schools per year?
Keep it short and to the point. 18.95. In the year 1971, what is the difference between the Gross enrolment ratio (%) in Pre-primary schools and Gross enrolment ratio (%) in Primary schools?
Your response must be concise. -91.26. In the year 1971, what is the difference between the Gross enrolment ratio (%) in Pre-primary schools and Gross enrolment ratio (%) in Secondary schools?
Provide a succinct answer. -17.12. In the year 1971, what is the difference between the Gross enrolment ratio (%) in Pre-primary schools and Gross enrolment ratio (%) in Tertiary schools?
Keep it short and to the point. -3.52. In the year 1971, what is the difference between the Gross enrolment ratio (%) of Primary schools and Gross enrolment ratio (%) of Secondary schools?
Make the answer very short. 74.14. In the year 1971, what is the difference between the Gross enrolment ratio (%) in Primary schools and Gross enrolment ratio (%) in Tertiary schools?
Provide a succinct answer. 87.74. In the year 1971, what is the difference between the Gross enrolment ratio (%) of Secondary schools and Gross enrolment ratio (%) of Tertiary schools?
Ensure brevity in your answer.  13.6. In the year 1972, what is the difference between the Gross enrolment ratio (%) in Pre-primary schools and Gross enrolment ratio (%) in Primary schools?
Provide a succinct answer. -95.62. In the year 1972, what is the difference between the Gross enrolment ratio (%) of Pre-primary schools and Gross enrolment ratio (%) of Secondary schools?
Your answer should be very brief. -17.98. In the year 1972, what is the difference between the Gross enrolment ratio (%) of Pre-primary schools and Gross enrolment ratio (%) of Tertiary schools?
Ensure brevity in your answer.  -4.29. In the year 1972, what is the difference between the Gross enrolment ratio (%) of Primary schools and Gross enrolment ratio (%) of Secondary schools?
Your answer should be very brief. 77.64. In the year 1972, what is the difference between the Gross enrolment ratio (%) of Primary schools and Gross enrolment ratio (%) of Tertiary schools?
Offer a very short reply. 91.33. In the year 1972, what is the difference between the Gross enrolment ratio (%) of Secondary schools and Gross enrolment ratio (%) of Tertiary schools?
Your answer should be very brief. 13.69. In the year 1973, what is the difference between the Gross enrolment ratio (%) of Pre-primary schools and Gross enrolment ratio (%) of Primary schools?
Your answer should be very brief. -94.5. In the year 1973, what is the difference between the Gross enrolment ratio (%) in Pre-primary schools and Gross enrolment ratio (%) in Secondary schools?
Your answer should be compact. -20.1. In the year 1973, what is the difference between the Gross enrolment ratio (%) in Pre-primary schools and Gross enrolment ratio (%) in Tertiary schools?
Keep it short and to the point. -4.78. In the year 1973, what is the difference between the Gross enrolment ratio (%) of Primary schools and Gross enrolment ratio (%) of Secondary schools?
Keep it short and to the point. 74.4. In the year 1973, what is the difference between the Gross enrolment ratio (%) in Primary schools and Gross enrolment ratio (%) in Tertiary schools?
Make the answer very short. 89.73. In the year 1973, what is the difference between the Gross enrolment ratio (%) in Secondary schools and Gross enrolment ratio (%) in Tertiary schools?
Your answer should be compact. 15.33. In the year 1974, what is the difference between the Gross enrolment ratio (%) in Pre-primary schools and Gross enrolment ratio (%) in Primary schools?
Your answer should be compact. -92.89. In the year 1974, what is the difference between the Gross enrolment ratio (%) in Pre-primary schools and Gross enrolment ratio (%) in Secondary schools?
Offer a very short reply. -21.38. In the year 1974, what is the difference between the Gross enrolment ratio (%) in Pre-primary schools and Gross enrolment ratio (%) in Tertiary schools?
Provide a short and direct response. -5.42. In the year 1974, what is the difference between the Gross enrolment ratio (%) in Primary schools and Gross enrolment ratio (%) in Secondary schools?
Give a very brief answer. 71.5. In the year 1974, what is the difference between the Gross enrolment ratio (%) of Primary schools and Gross enrolment ratio (%) of Tertiary schools?
Offer a terse response. 87.47. In the year 1974, what is the difference between the Gross enrolment ratio (%) in Secondary schools and Gross enrolment ratio (%) in Tertiary schools?
Your answer should be compact. 15.96. In the year 1975, what is the difference between the Gross enrolment ratio (%) of Pre-primary schools and Gross enrolment ratio (%) of Primary schools?
Offer a very short reply. -94.49. In the year 1975, what is the difference between the Gross enrolment ratio (%) of Pre-primary schools and Gross enrolment ratio (%) of Secondary schools?
Provide a succinct answer. -22.45. In the year 1975, what is the difference between the Gross enrolment ratio (%) of Pre-primary schools and Gross enrolment ratio (%) of Tertiary schools?
Ensure brevity in your answer.  -14.97. In the year 1975, what is the difference between the Gross enrolment ratio (%) of Primary schools and Gross enrolment ratio (%) of Secondary schools?
Provide a short and direct response. 72.04. In the year 1975, what is the difference between the Gross enrolment ratio (%) of Primary schools and Gross enrolment ratio (%) of Tertiary schools?
Ensure brevity in your answer.  79.52. In the year 1975, what is the difference between the Gross enrolment ratio (%) of Secondary schools and Gross enrolment ratio (%) of Tertiary schools?
Ensure brevity in your answer.  7.48. In the year 1976, what is the difference between the Gross enrolment ratio (%) in Pre-primary schools and Gross enrolment ratio (%) in Primary schools?
Offer a very short reply. -97.59. In the year 1976, what is the difference between the Gross enrolment ratio (%) of Pre-primary schools and Gross enrolment ratio (%) of Secondary schools?
Ensure brevity in your answer.  -30.57. In the year 1976, what is the difference between the Gross enrolment ratio (%) of Pre-primary schools and Gross enrolment ratio (%) of Tertiary schools?
Give a very brief answer. -18.85. In the year 1976, what is the difference between the Gross enrolment ratio (%) of Primary schools and Gross enrolment ratio (%) of Secondary schools?
Your response must be concise. 67.02. In the year 1976, what is the difference between the Gross enrolment ratio (%) in Primary schools and Gross enrolment ratio (%) in Tertiary schools?
Your answer should be compact. 78.74. In the year 1976, what is the difference between the Gross enrolment ratio (%) in Secondary schools and Gross enrolment ratio (%) in Tertiary schools?
Give a very brief answer. 11.72. In the year 1977, what is the difference between the Gross enrolment ratio (%) in Pre-primary schools and Gross enrolment ratio (%) in Primary schools?
Offer a very short reply. -98.69. In the year 1977, what is the difference between the Gross enrolment ratio (%) in Pre-primary schools and Gross enrolment ratio (%) in Secondary schools?
Give a very brief answer. -32.01. In the year 1977, what is the difference between the Gross enrolment ratio (%) in Pre-primary schools and Gross enrolment ratio (%) in Tertiary schools?
Offer a terse response. -29.55. In the year 1977, what is the difference between the Gross enrolment ratio (%) of Primary schools and Gross enrolment ratio (%) of Secondary schools?
Make the answer very short. 66.68. In the year 1977, what is the difference between the Gross enrolment ratio (%) in Primary schools and Gross enrolment ratio (%) in Tertiary schools?
Ensure brevity in your answer.  69.14. In the year 1977, what is the difference between the Gross enrolment ratio (%) of Secondary schools and Gross enrolment ratio (%) of Tertiary schools?
Your answer should be very brief. 2.46. In the year 1978, what is the difference between the Gross enrolment ratio (%) of Pre-primary schools and Gross enrolment ratio (%) of Primary schools?
Provide a succinct answer. -98.6. In the year 1978, what is the difference between the Gross enrolment ratio (%) of Pre-primary schools and Gross enrolment ratio (%) of Secondary schools?
Offer a very short reply. -33.48. In the year 1978, what is the difference between the Gross enrolment ratio (%) in Pre-primary schools and Gross enrolment ratio (%) in Tertiary schools?
Provide a succinct answer. -42.57. In the year 1978, what is the difference between the Gross enrolment ratio (%) in Primary schools and Gross enrolment ratio (%) in Secondary schools?
Make the answer very short. 65.12. In the year 1978, what is the difference between the Gross enrolment ratio (%) in Primary schools and Gross enrolment ratio (%) in Tertiary schools?
Your answer should be compact. 56.03. In the year 1978, what is the difference between the Gross enrolment ratio (%) of Secondary schools and Gross enrolment ratio (%) of Tertiary schools?
Keep it short and to the point. -9.09. What is the ratio of the Gross enrolment ratio (%) of Pre-primary schools in 1971 to that in 1972?
Ensure brevity in your answer.  0.82. What is the ratio of the Gross enrolment ratio (%) in Primary schools in 1971 to that in 1972?
Your response must be concise. 0.95. What is the ratio of the Gross enrolment ratio (%) in Secondary schools in 1971 to that in 1972?
Offer a very short reply. 0.93. What is the ratio of the Gross enrolment ratio (%) of Tertiary schools in 1971 to that in 1972?
Your response must be concise. 0.82. What is the ratio of the Gross enrolment ratio (%) in Pre-primary schools in 1971 to that in 1973?
Make the answer very short. 0.8. What is the ratio of the Gross enrolment ratio (%) of Primary schools in 1971 to that in 1973?
Offer a terse response. 0.96. What is the ratio of the Gross enrolment ratio (%) in Secondary schools in 1971 to that in 1973?
Give a very brief answer. 0.84. What is the ratio of the Gross enrolment ratio (%) of Tertiary schools in 1971 to that in 1973?
Your answer should be very brief. 0.76. What is the ratio of the Gross enrolment ratio (%) in Pre-primary schools in 1971 to that in 1974?
Make the answer very short. 0.8. What is the ratio of the Gross enrolment ratio (%) of Primary schools in 1971 to that in 1974?
Provide a succinct answer. 0.98. What is the ratio of the Gross enrolment ratio (%) of Secondary schools in 1971 to that in 1974?
Provide a short and direct response. 0.8. What is the ratio of the Gross enrolment ratio (%) of Tertiary schools in 1971 to that in 1974?
Make the answer very short. 0.71. What is the ratio of the Gross enrolment ratio (%) in Pre-primary schools in 1971 to that in 1975?
Your answer should be compact. 0.78. What is the ratio of the Gross enrolment ratio (%) of Primary schools in 1971 to that in 1975?
Give a very brief answer. 0.96. What is the ratio of the Gross enrolment ratio (%) in Secondary schools in 1971 to that in 1975?
Your answer should be compact. 0.76. What is the ratio of the Gross enrolment ratio (%) in Tertiary schools in 1971 to that in 1975?
Keep it short and to the point. 0.34. What is the ratio of the Gross enrolment ratio (%) of Pre-primary schools in 1971 to that in 1976?
Ensure brevity in your answer.  0.74. What is the ratio of the Gross enrolment ratio (%) in Primary schools in 1971 to that in 1976?
Keep it short and to the point. 0.93. What is the ratio of the Gross enrolment ratio (%) in Secondary schools in 1971 to that in 1976?
Your answer should be compact. 0.58. What is the ratio of the Gross enrolment ratio (%) in Tertiary schools in 1971 to that in 1976?
Make the answer very short. 0.28. What is the ratio of the Gross enrolment ratio (%) of Pre-primary schools in 1971 to that in 1977?
Your answer should be compact. 0.72. What is the ratio of the Gross enrolment ratio (%) in Primary schools in 1971 to that in 1977?
Your answer should be compact. 0.92. What is the ratio of the Gross enrolment ratio (%) in Secondary schools in 1971 to that in 1977?
Provide a succinct answer. 0.55. What is the ratio of the Gross enrolment ratio (%) in Tertiary schools in 1971 to that in 1977?
Make the answer very short. 0.19. What is the ratio of the Gross enrolment ratio (%) of Pre-primary schools in 1971 to that in 1978?
Your answer should be compact. 0.72. What is the ratio of the Gross enrolment ratio (%) of Primary schools in 1971 to that in 1978?
Your answer should be compact. 0.92. What is the ratio of the Gross enrolment ratio (%) of Secondary schools in 1971 to that in 1978?
Make the answer very short. 0.53. What is the ratio of the Gross enrolment ratio (%) of Tertiary schools in 1971 to that in 1978?
Your answer should be very brief. 0.13. What is the ratio of the Gross enrolment ratio (%) of Pre-primary schools in 1972 to that in 1973?
Offer a terse response. 0.97. What is the ratio of the Gross enrolment ratio (%) in Primary schools in 1972 to that in 1973?
Provide a succinct answer. 1.01. What is the ratio of the Gross enrolment ratio (%) of Secondary schools in 1972 to that in 1973?
Offer a very short reply. 0.91. What is the ratio of the Gross enrolment ratio (%) of Tertiary schools in 1972 to that in 1973?
Provide a succinct answer. 0.93. What is the ratio of the Gross enrolment ratio (%) of Pre-primary schools in 1972 to that in 1974?
Make the answer very short. 0.97. What is the ratio of the Gross enrolment ratio (%) in Primary schools in 1972 to that in 1974?
Provide a succinct answer. 1.03. What is the ratio of the Gross enrolment ratio (%) in Secondary schools in 1972 to that in 1974?
Offer a terse response. 0.86. What is the ratio of the Gross enrolment ratio (%) in Tertiary schools in 1972 to that in 1974?
Keep it short and to the point. 0.86. What is the ratio of the Gross enrolment ratio (%) in Pre-primary schools in 1972 to that in 1975?
Offer a very short reply. 0.95. What is the ratio of the Gross enrolment ratio (%) in Primary schools in 1972 to that in 1975?
Ensure brevity in your answer.  1.01. What is the ratio of the Gross enrolment ratio (%) in Secondary schools in 1972 to that in 1975?
Your response must be concise. 0.82. What is the ratio of the Gross enrolment ratio (%) of Tertiary schools in 1972 to that in 1975?
Provide a succinct answer. 0.41. What is the ratio of the Gross enrolment ratio (%) of Pre-primary schools in 1972 to that in 1976?
Offer a very short reply. 0.9. What is the ratio of the Gross enrolment ratio (%) of Primary schools in 1972 to that in 1976?
Give a very brief answer. 0.98. What is the ratio of the Gross enrolment ratio (%) in Secondary schools in 1972 to that in 1976?
Your response must be concise. 0.62. What is the ratio of the Gross enrolment ratio (%) in Tertiary schools in 1972 to that in 1976?
Make the answer very short. 0.34. What is the ratio of the Gross enrolment ratio (%) in Pre-primary schools in 1972 to that in 1977?
Provide a short and direct response. 0.88. What is the ratio of the Gross enrolment ratio (%) in Primary schools in 1972 to that in 1977?
Your answer should be compact. 0.97. What is the ratio of the Gross enrolment ratio (%) in Secondary schools in 1972 to that in 1977?
Provide a succinct answer. 0.6. What is the ratio of the Gross enrolment ratio (%) of Tertiary schools in 1972 to that in 1977?
Your response must be concise. 0.23. What is the ratio of the Gross enrolment ratio (%) in Pre-primary schools in 1972 to that in 1978?
Make the answer very short. 0.87. What is the ratio of the Gross enrolment ratio (%) in Primary schools in 1972 to that in 1978?
Give a very brief answer. 0.97. What is the ratio of the Gross enrolment ratio (%) of Secondary schools in 1972 to that in 1978?
Make the answer very short. 0.57. What is the ratio of the Gross enrolment ratio (%) in Tertiary schools in 1972 to that in 1978?
Offer a very short reply. 0.16. What is the ratio of the Gross enrolment ratio (%) in Pre-primary schools in 1973 to that in 1974?
Your answer should be very brief. 1. What is the ratio of the Gross enrolment ratio (%) in Primary schools in 1973 to that in 1974?
Make the answer very short. 1.02. What is the ratio of the Gross enrolment ratio (%) in Secondary schools in 1973 to that in 1974?
Provide a short and direct response. 0.95. What is the ratio of the Gross enrolment ratio (%) in Tertiary schools in 1973 to that in 1974?
Provide a short and direct response. 0.93. What is the ratio of the Gross enrolment ratio (%) in Pre-primary schools in 1973 to that in 1975?
Your response must be concise. 0.97. What is the ratio of the Gross enrolment ratio (%) of Secondary schools in 1973 to that in 1975?
Offer a terse response. 0.91. What is the ratio of the Gross enrolment ratio (%) of Tertiary schools in 1973 to that in 1975?
Provide a succinct answer. 0.44. What is the ratio of the Gross enrolment ratio (%) in Pre-primary schools in 1973 to that in 1976?
Your answer should be compact. 0.93. What is the ratio of the Gross enrolment ratio (%) in Primary schools in 1973 to that in 1976?
Your answer should be very brief. 0.97. What is the ratio of the Gross enrolment ratio (%) in Secondary schools in 1973 to that in 1976?
Ensure brevity in your answer.  0.69. What is the ratio of the Gross enrolment ratio (%) of Tertiary schools in 1973 to that in 1976?
Provide a succinct answer. 0.36. What is the ratio of the Gross enrolment ratio (%) of Pre-primary schools in 1973 to that in 1977?
Give a very brief answer. 0.91. What is the ratio of the Gross enrolment ratio (%) of Primary schools in 1973 to that in 1977?
Your answer should be very brief. 0.96. What is the ratio of the Gross enrolment ratio (%) of Secondary schools in 1973 to that in 1977?
Give a very brief answer. 0.66. What is the ratio of the Gross enrolment ratio (%) of Tertiary schools in 1973 to that in 1977?
Keep it short and to the point. 0.25. What is the ratio of the Gross enrolment ratio (%) in Pre-primary schools in 1973 to that in 1978?
Provide a short and direct response. 0.9. What is the ratio of the Gross enrolment ratio (%) in Primary schools in 1973 to that in 1978?
Provide a succinct answer. 0.96. What is the ratio of the Gross enrolment ratio (%) in Secondary schools in 1973 to that in 1978?
Provide a short and direct response. 0.63. What is the ratio of the Gross enrolment ratio (%) in Tertiary schools in 1973 to that in 1978?
Ensure brevity in your answer.  0.18. What is the ratio of the Gross enrolment ratio (%) in Pre-primary schools in 1974 to that in 1975?
Provide a succinct answer. 0.98. What is the ratio of the Gross enrolment ratio (%) of Primary schools in 1974 to that in 1975?
Give a very brief answer. 0.98. What is the ratio of the Gross enrolment ratio (%) in Secondary schools in 1974 to that in 1975?
Your response must be concise. 0.96. What is the ratio of the Gross enrolment ratio (%) of Tertiary schools in 1974 to that in 1975?
Provide a succinct answer. 0.48. What is the ratio of the Gross enrolment ratio (%) of Pre-primary schools in 1974 to that in 1976?
Keep it short and to the point. 0.93. What is the ratio of the Gross enrolment ratio (%) of Primary schools in 1974 to that in 1976?
Provide a short and direct response. 0.95. What is the ratio of the Gross enrolment ratio (%) in Secondary schools in 1974 to that in 1976?
Provide a succinct answer. 0.72. What is the ratio of the Gross enrolment ratio (%) of Tertiary schools in 1974 to that in 1976?
Ensure brevity in your answer.  0.39. What is the ratio of the Gross enrolment ratio (%) of Primary schools in 1974 to that in 1977?
Give a very brief answer. 0.94. What is the ratio of the Gross enrolment ratio (%) in Secondary schools in 1974 to that in 1977?
Give a very brief answer. 0.69. What is the ratio of the Gross enrolment ratio (%) of Tertiary schools in 1974 to that in 1977?
Offer a terse response. 0.27. What is the ratio of the Gross enrolment ratio (%) in Pre-primary schools in 1974 to that in 1978?
Your response must be concise. 0.9. What is the ratio of the Gross enrolment ratio (%) in Primary schools in 1974 to that in 1978?
Ensure brevity in your answer.  0.94. What is the ratio of the Gross enrolment ratio (%) in Secondary schools in 1974 to that in 1978?
Offer a terse response. 0.67. What is the ratio of the Gross enrolment ratio (%) of Tertiary schools in 1974 to that in 1978?
Your answer should be very brief. 0.19. What is the ratio of the Gross enrolment ratio (%) of Pre-primary schools in 1975 to that in 1976?
Your answer should be very brief. 0.95. What is the ratio of the Gross enrolment ratio (%) of Secondary schools in 1975 to that in 1976?
Your answer should be very brief. 0.76. What is the ratio of the Gross enrolment ratio (%) of Tertiary schools in 1975 to that in 1976?
Ensure brevity in your answer.  0.82. What is the ratio of the Gross enrolment ratio (%) of Pre-primary schools in 1975 to that in 1977?
Offer a very short reply. 0.93. What is the ratio of the Gross enrolment ratio (%) of Primary schools in 1975 to that in 1977?
Your response must be concise. 0.96. What is the ratio of the Gross enrolment ratio (%) of Secondary schools in 1975 to that in 1977?
Give a very brief answer. 0.73. What is the ratio of the Gross enrolment ratio (%) of Tertiary schools in 1975 to that in 1977?
Keep it short and to the point. 0.55. What is the ratio of the Gross enrolment ratio (%) of Pre-primary schools in 1975 to that in 1978?
Your response must be concise. 0.92. What is the ratio of the Gross enrolment ratio (%) in Secondary schools in 1975 to that in 1978?
Provide a succinct answer. 0.7. What is the ratio of the Gross enrolment ratio (%) of Tertiary schools in 1975 to that in 1978?
Your answer should be very brief. 0.4. What is the ratio of the Gross enrolment ratio (%) of Pre-primary schools in 1976 to that in 1977?
Your answer should be compact. 0.97. What is the ratio of the Gross enrolment ratio (%) in Primary schools in 1976 to that in 1977?
Give a very brief answer. 0.99. What is the ratio of the Gross enrolment ratio (%) of Secondary schools in 1976 to that in 1977?
Provide a short and direct response. 0.96. What is the ratio of the Gross enrolment ratio (%) in Tertiary schools in 1976 to that in 1977?
Your answer should be very brief. 0.68. What is the ratio of the Gross enrolment ratio (%) in Pre-primary schools in 1976 to that in 1978?
Ensure brevity in your answer.  0.97. What is the ratio of the Gross enrolment ratio (%) of Primary schools in 1976 to that in 1978?
Keep it short and to the point. 0.99. What is the ratio of the Gross enrolment ratio (%) in Secondary schools in 1976 to that in 1978?
Give a very brief answer. 0.92. What is the ratio of the Gross enrolment ratio (%) in Tertiary schools in 1976 to that in 1978?
Keep it short and to the point. 0.49. What is the ratio of the Gross enrolment ratio (%) of Pre-primary schools in 1977 to that in 1978?
Make the answer very short. 0.99. What is the ratio of the Gross enrolment ratio (%) in Secondary schools in 1977 to that in 1978?
Give a very brief answer. 0.96. What is the ratio of the Gross enrolment ratio (%) in Tertiary schools in 1977 to that in 1978?
Ensure brevity in your answer.  0.72. What is the difference between the highest and the second highest Gross enrolment ratio (%) in Pre-primary schools?
Your answer should be very brief. 0.03. What is the difference between the highest and the second highest Gross enrolment ratio (%) of Primary schools?
Offer a very short reply. 0.06. What is the difference between the highest and the second highest Gross enrolment ratio (%) in Secondary schools?
Ensure brevity in your answer.  1.5. What is the difference between the highest and the second highest Gross enrolment ratio (%) in Tertiary schools?
Your answer should be very brief. 13.05. What is the difference between the highest and the lowest Gross enrolment ratio (%) of Pre-primary schools?
Offer a terse response. 1.07. What is the difference between the highest and the lowest Gross enrolment ratio (%) of Primary schools?
Ensure brevity in your answer.  8.47. What is the difference between the highest and the lowest Gross enrolment ratio (%) in Secondary schools?
Your answer should be compact. 17.43. What is the difference between the highest and the lowest Gross enrolment ratio (%) of Tertiary schools?
Offer a terse response. 40.12. 